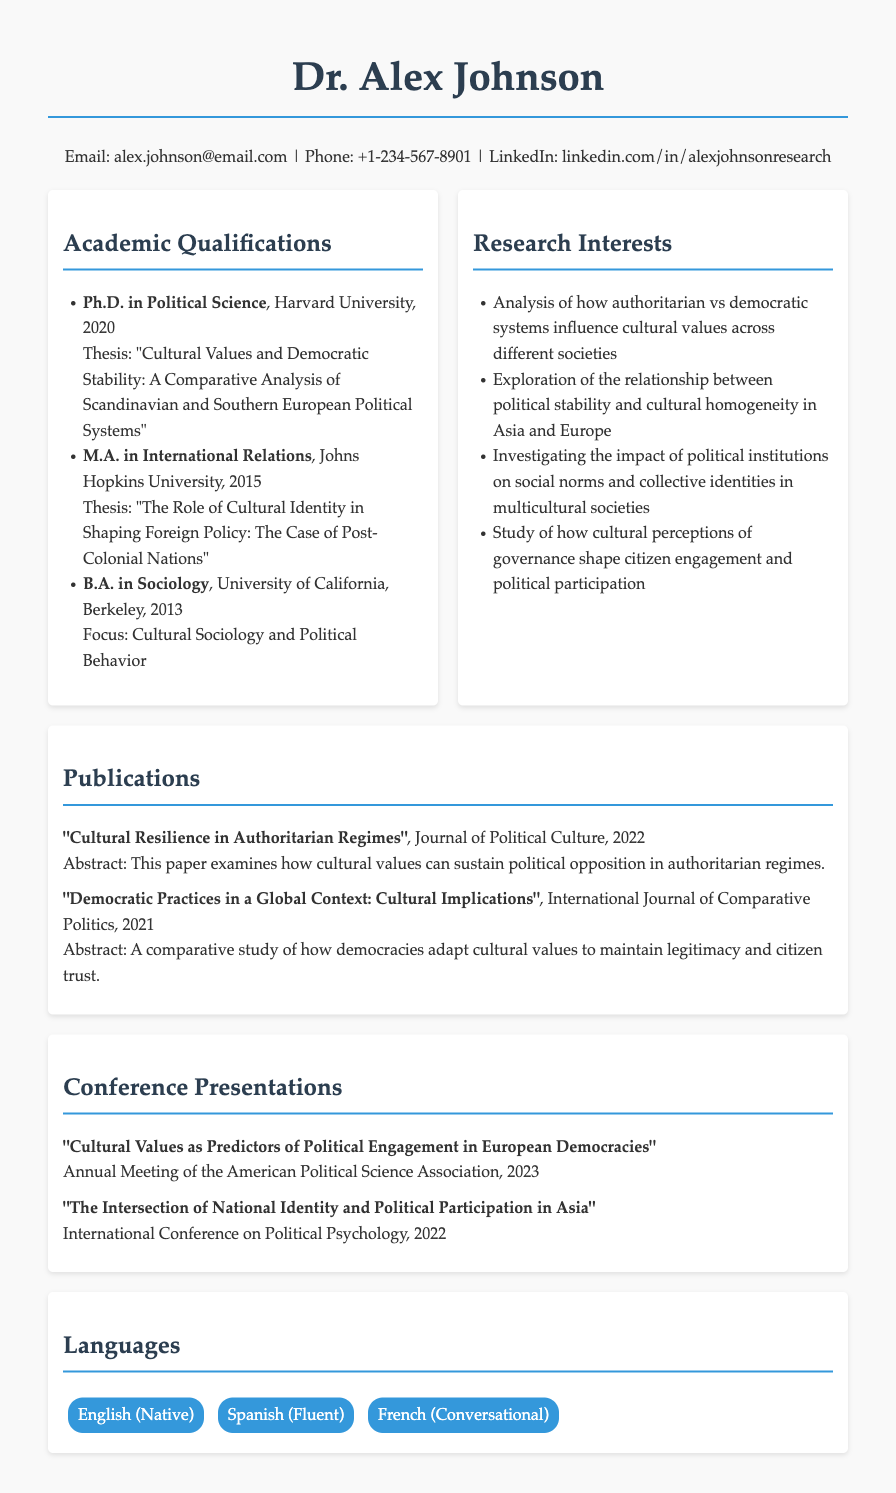What is Dr. Alex Johnson's highest academic qualification? The highest academic qualification listed in the resume is a Ph.D. in Political Science.
Answer: Ph.D. in Political Science What university did Dr. Alex Johnson obtain their Ph.D. from? The document states that Dr. Alex Johnson earned their Ph.D. from Harvard University.
Answer: Harvard University What was the focus of Dr. Johnson's B.A. thesis? The focus mentioned for the B.A. in Sociology is on Cultural Sociology and Political Behavior.
Answer: Cultural Sociology and Political Behavior How many conference presentations are listed in the resume? There are two conference presentations listed in the document.
Answer: 2 What is one of Dr. Johnson's research interests? One of the research interests mentioned is the analysis of how authoritarian vs democratic systems influence cultural values.
Answer: Authoritarian vs democratic systems What year was Dr. Johnson's publication "Cultural Resilience in Authoritarian Regimes" released? The publication year for "Cultural Resilience in Authoritarian Regimes" is stated as 2022.
Answer: 2022 In what capacity does Dr. Johnson explore cultural values and political systems? Dr. Johnson explores this intersection primarily through analysis and investigation of their influence on democratic stability and political engagement.
Answer: Analysis and investigation What type of degree is a Master's in International Relations considered? The document lists this degree as a graduate-level academic qualification.
Answer: Graduate-level qualification 